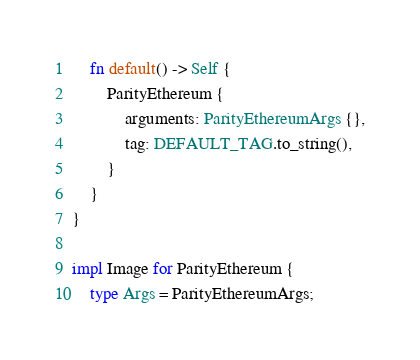Convert code to text. <code><loc_0><loc_0><loc_500><loc_500><_Rust_>    fn default() -> Self {
        ParityEthereum {
            arguments: ParityEthereumArgs {},
            tag: DEFAULT_TAG.to_string(),
        }
    }
}

impl Image for ParityEthereum {
    type Args = ParityEthereumArgs;</code> 